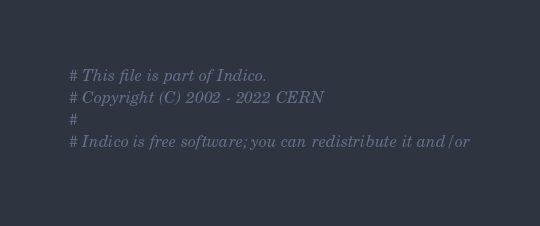Convert code to text. <code><loc_0><loc_0><loc_500><loc_500><_Python_># This file is part of Indico.
# Copyright (C) 2002 - 2022 CERN
#
# Indico is free software; you can redistribute it and/or</code> 